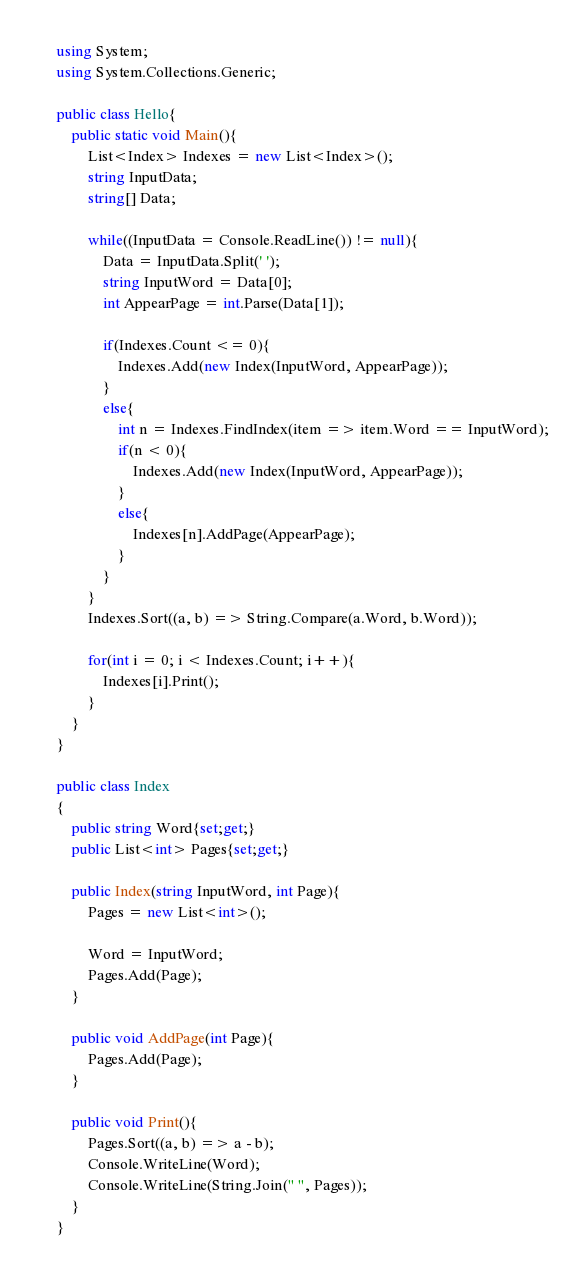<code> <loc_0><loc_0><loc_500><loc_500><_C#_>using System;
using System.Collections.Generic;

public class Hello{
    public static void Main(){
        List<Index> Indexes = new List<Index>();
        string InputData;
        string[] Data;
        
        while((InputData = Console.ReadLine()) != null){
            Data = InputData.Split(' ');
            string InputWord = Data[0];
            int AppearPage = int.Parse(Data[1]);
            
            if(Indexes.Count <= 0){
                Indexes.Add(new Index(InputWord, AppearPage));
            }
            else{
                int n = Indexes.FindIndex(item => item.Word == InputWord);
                if(n < 0){
                    Indexes.Add(new Index(InputWord, AppearPage));
                }
                else{
                    Indexes[n].AddPage(AppearPage);
                }
            }
        }
        Indexes.Sort((a, b) => String.Compare(a.Word, b.Word));
    
        for(int i = 0; i < Indexes.Count; i++){
            Indexes[i].Print();
        }
    }
}

public class Index
{
    public string Word{set;get;}
    public List<int> Pages{set;get;}
    
    public Index(string InputWord, int Page){
        Pages = new List<int>();
        
        Word = InputWord;
        Pages.Add(Page);
    }
    
    public void AddPage(int Page){
        Pages.Add(Page);
    }
    
    public void Print(){
        Pages.Sort((a, b) => a - b);
        Console.WriteLine(Word);
        Console.WriteLine(String.Join(" ", Pages));
    }
}</code> 